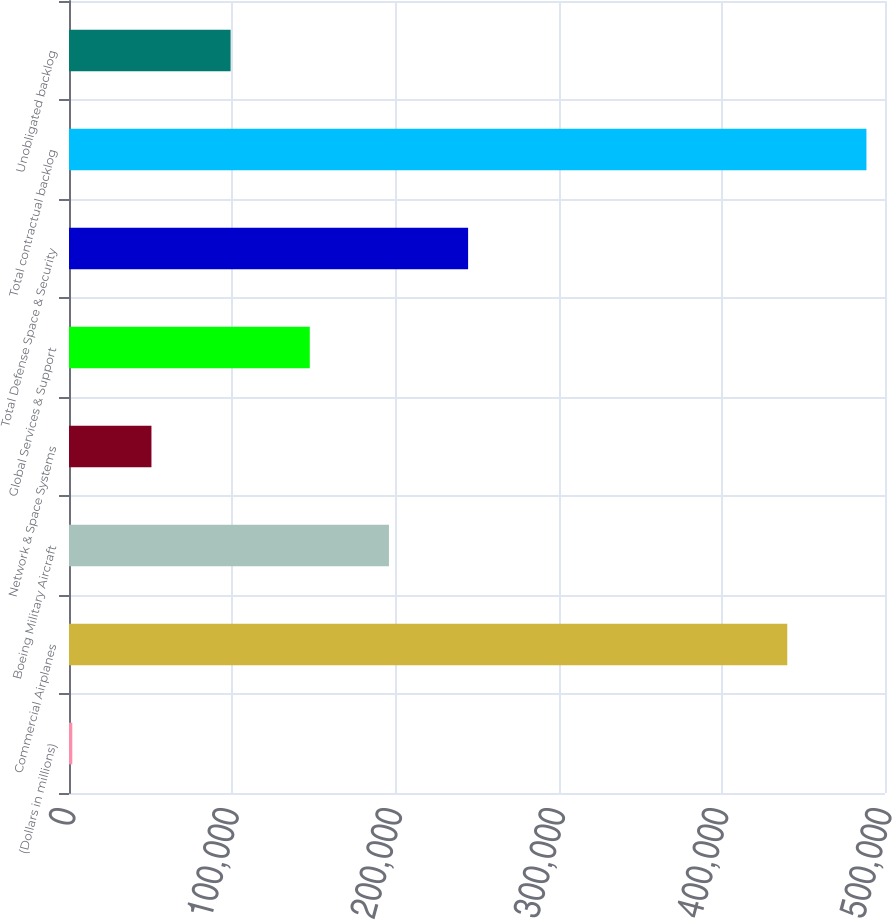<chart> <loc_0><loc_0><loc_500><loc_500><bar_chart><fcel>(Dollars in millions)<fcel>Commercial Airplanes<fcel>Boeing Military Aircraft<fcel>Network & Space Systems<fcel>Global Services & Support<fcel>Total Defense Space & Security<fcel>Total contractual backlog<fcel>Unobligated backlog<nl><fcel>2014<fcel>440118<fcel>196045<fcel>50521.8<fcel>147537<fcel>244553<fcel>488626<fcel>99029.6<nl></chart> 